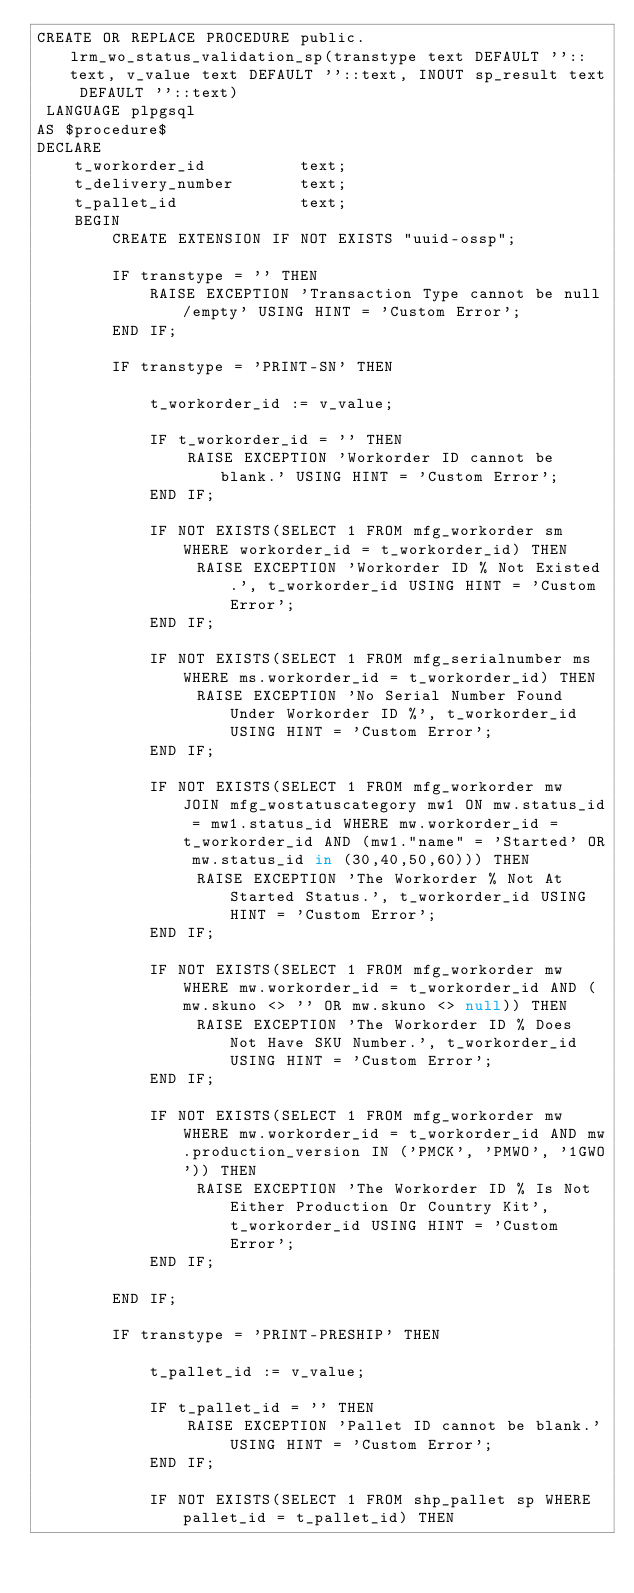<code> <loc_0><loc_0><loc_500><loc_500><_SQL_>CREATE OR REPLACE PROCEDURE public.lrm_wo_status_validation_sp(transtype text DEFAULT ''::text, v_value text DEFAULT ''::text, INOUT sp_result text DEFAULT ''::text)
 LANGUAGE plpgsql
AS $procedure$
DECLARE 
	t_workorder_id			text;
	t_delivery_number		text;
	t_pallet_id				text;
	BEGIN
        CREATE EXTENSION IF NOT EXISTS "uuid-ossp";
       
		IF transtype = '' THEN
			RAISE EXCEPTION 'Transaction Type cannot be null/empty' USING HINT = 'Custom Error';
		END IF;	

		IF transtype = 'PRINT-SN' THEN

			t_workorder_id := v_value;

			IF t_workorder_id = '' THEN
				RAISE EXCEPTION 'Workorder ID cannot be blank.' USING HINT = 'Custom Error';
			END IF; 
		
			IF NOT EXISTS(SELECT 1 FROM mfg_workorder sm WHERE workorder_id = t_workorder_id) THEN
		         RAISE EXCEPTION 'Workorder ID % Not Existed.', t_workorder_id USING HINT = 'Custom Error';
		    END IF;
		   
		    IF NOT EXISTS(SELECT 1 FROM mfg_serialnumber ms WHERE ms.workorder_id = t_workorder_id) THEN
		         RAISE EXCEPTION 'No Serial Number Found Under Workorder ID %', t_workorder_id USING HINT = 'Custom Error';
		    END IF;
		   	       
		    IF NOT EXISTS(SELECT 1 FROM mfg_workorder mw JOIN mfg_wostatuscategory mw1 ON mw.status_id = mw1.status_id WHERE mw.workorder_id = t_workorder_id AND (mw1."name" = 'Started' OR mw.status_id in (30,40,50,60))) THEN
		         RAISE EXCEPTION 'The Workorder % Not At Started Status.', t_workorder_id USING HINT = 'Custom Error';
		    END IF;
		   
		    IF NOT EXISTS(SELECT 1 FROM mfg_workorder mw WHERE mw.workorder_id = t_workorder_id AND (mw.skuno <> '' OR mw.skuno <> null)) THEN
		         RAISE EXCEPTION 'The Workorder ID % Does Not Have SKU Number.', t_workorder_id USING HINT = 'Custom Error';
		    END IF;
		   
		    IF NOT EXISTS(SELECT 1 FROM mfg_workorder mw WHERE mw.workorder_id = t_workorder_id AND mw.production_version IN ('PMCK', 'PMWO', '1GWO')) THEN
		         RAISE EXCEPTION 'The Workorder ID % Is Not Either Production Or Country Kit', t_workorder_id USING HINT = 'Custom Error';
		    END IF;
		   		   
		END IF;	
	
		IF transtype = 'PRINT-PRESHIP' THEN

			t_pallet_id := v_value;

			IF t_pallet_id = '' THEN
				RAISE EXCEPTION 'Pallet ID cannot be blank.' USING HINT = 'Custom Error';
			END IF; 
		
			IF NOT EXISTS(SELECT 1 FROM shp_pallet sp WHERE pallet_id = t_pallet_id) THEN</code> 